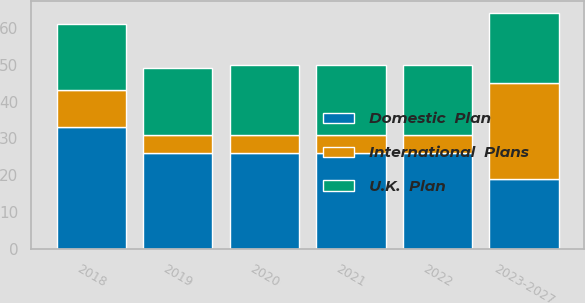Convert chart to OTSL. <chart><loc_0><loc_0><loc_500><loc_500><stacked_bar_chart><ecel><fcel>2018<fcel>2019<fcel>2020<fcel>2021<fcel>2022<fcel>2023-2027<nl><fcel>Domestic  Plan<fcel>33<fcel>26<fcel>26<fcel>26<fcel>26<fcel>19<nl><fcel>U.K.  Plan<fcel>18<fcel>18<fcel>19<fcel>19<fcel>19<fcel>19<nl><fcel>International  Plans<fcel>10<fcel>5<fcel>5<fcel>5<fcel>5<fcel>26<nl></chart> 